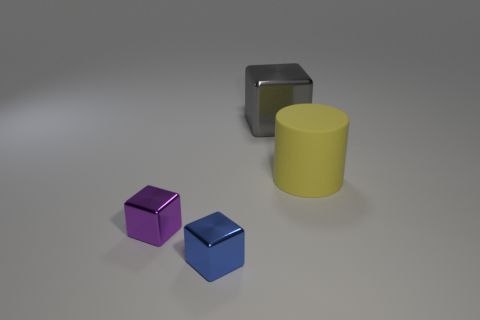Can you infer anything about the lighting in this scene? The scene is lit from above, as indicated by the soft shadows directly underneath the objects. The even, diffused nature of the lighting suggests it could be from a studio light or a cloudy sky if the scene were set outdoors. There are no harsh or highly directional shadows, so it's likely a single main light source is being used. 